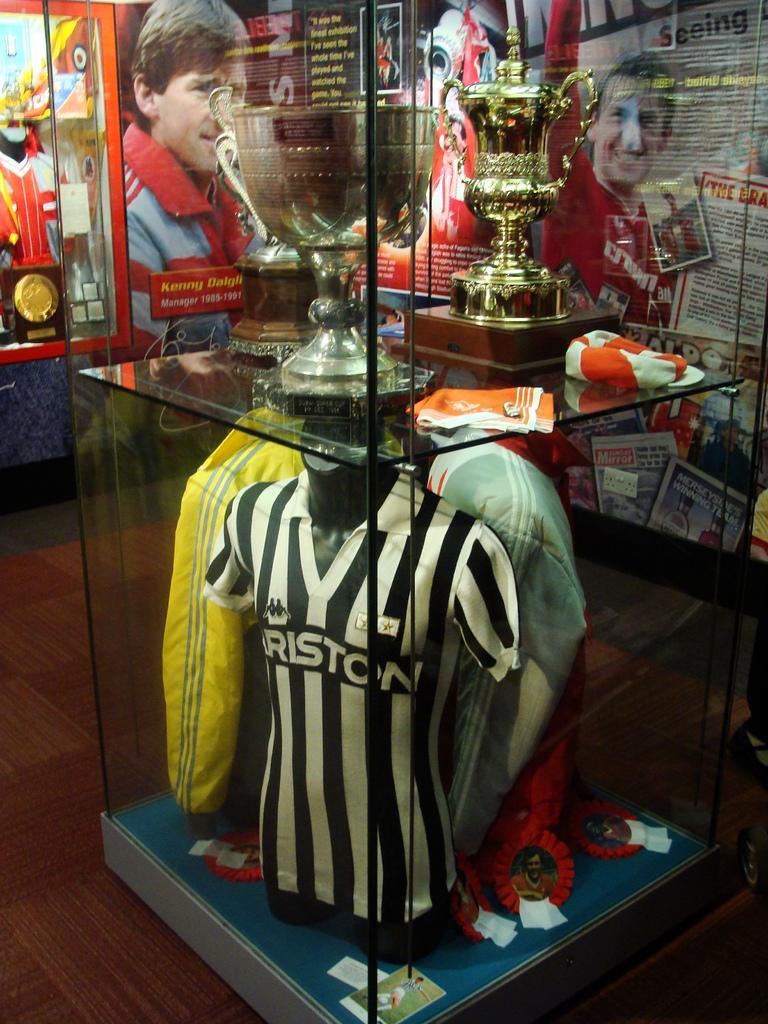Can you describe this image briefly? Inside this glass box we can see t-shirts, badges, trophies and things. Background there are posters. 